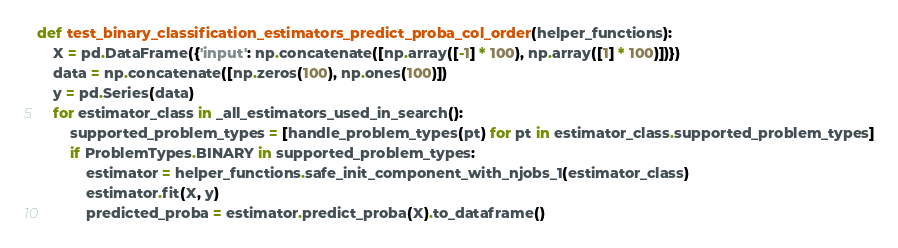<code> <loc_0><loc_0><loc_500><loc_500><_Python_>

def test_binary_classification_estimators_predict_proba_col_order(helper_functions):
    X = pd.DataFrame({'input': np.concatenate([np.array([-1] * 100), np.array([1] * 100)])})
    data = np.concatenate([np.zeros(100), np.ones(100)])
    y = pd.Series(data)
    for estimator_class in _all_estimators_used_in_search():
        supported_problem_types = [handle_problem_types(pt) for pt in estimator_class.supported_problem_types]
        if ProblemTypes.BINARY in supported_problem_types:
            estimator = helper_functions.safe_init_component_with_njobs_1(estimator_class)
            estimator.fit(X, y)
            predicted_proba = estimator.predict_proba(X).to_dataframe()</code> 